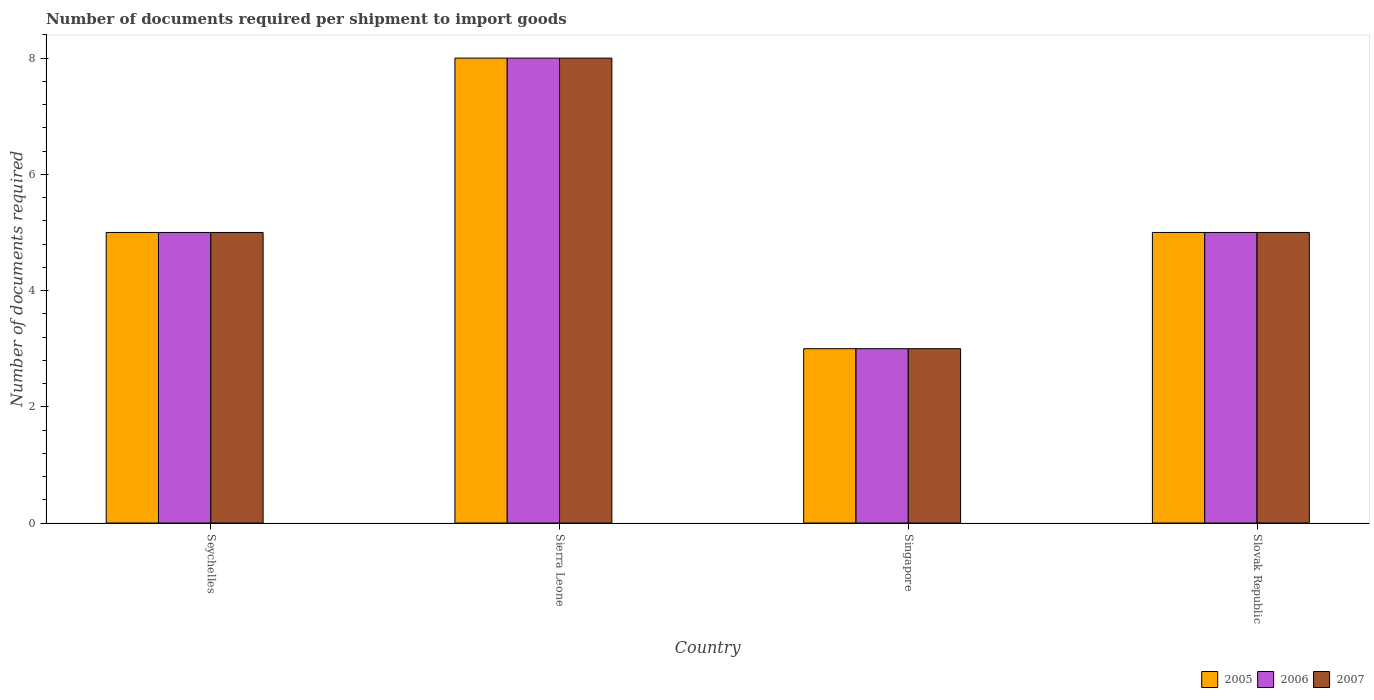How many groups of bars are there?
Offer a very short reply. 4. Are the number of bars per tick equal to the number of legend labels?
Your answer should be compact. Yes. What is the label of the 4th group of bars from the left?
Ensure brevity in your answer.  Slovak Republic. Across all countries, what is the maximum number of documents required per shipment to import goods in 2006?
Ensure brevity in your answer.  8. In which country was the number of documents required per shipment to import goods in 2007 maximum?
Offer a terse response. Sierra Leone. In which country was the number of documents required per shipment to import goods in 2006 minimum?
Your response must be concise. Singapore. What is the difference between the number of documents required per shipment to import goods in 2006 in Seychelles and that in Singapore?
Make the answer very short. 2. What is the average number of documents required per shipment to import goods in 2007 per country?
Give a very brief answer. 5.25. What is the difference between the number of documents required per shipment to import goods of/in 2006 and number of documents required per shipment to import goods of/in 2007 in Seychelles?
Your response must be concise. 0. What is the ratio of the number of documents required per shipment to import goods in 2005 in Seychelles to that in Singapore?
Provide a short and direct response. 1.67. Is the number of documents required per shipment to import goods in 2005 in Seychelles less than that in Sierra Leone?
Ensure brevity in your answer.  Yes. Is the difference between the number of documents required per shipment to import goods in 2006 in Seychelles and Sierra Leone greater than the difference between the number of documents required per shipment to import goods in 2007 in Seychelles and Sierra Leone?
Ensure brevity in your answer.  No. What is the difference between the highest and the second highest number of documents required per shipment to import goods in 2006?
Keep it short and to the point. 3. What is the difference between the highest and the lowest number of documents required per shipment to import goods in 2005?
Make the answer very short. 5. What does the 3rd bar from the left in Sierra Leone represents?
Offer a terse response. 2007. What does the 2nd bar from the right in Sierra Leone represents?
Keep it short and to the point. 2006. How many countries are there in the graph?
Your answer should be very brief. 4. Does the graph contain any zero values?
Keep it short and to the point. No. Where does the legend appear in the graph?
Offer a terse response. Bottom right. What is the title of the graph?
Provide a succinct answer. Number of documents required per shipment to import goods. Does "2005" appear as one of the legend labels in the graph?
Provide a succinct answer. Yes. What is the label or title of the Y-axis?
Offer a terse response. Number of documents required. What is the Number of documents required in 2007 in Seychelles?
Ensure brevity in your answer.  5. What is the Number of documents required of 2006 in Sierra Leone?
Your answer should be compact. 8. What is the Number of documents required in 2007 in Sierra Leone?
Provide a succinct answer. 8. What is the Number of documents required in 2005 in Singapore?
Keep it short and to the point. 3. What is the Number of documents required in 2007 in Singapore?
Offer a very short reply. 3. Across all countries, what is the maximum Number of documents required in 2005?
Your response must be concise. 8. Across all countries, what is the maximum Number of documents required of 2007?
Offer a terse response. 8. Across all countries, what is the minimum Number of documents required of 2006?
Ensure brevity in your answer.  3. Across all countries, what is the minimum Number of documents required in 2007?
Make the answer very short. 3. What is the total Number of documents required of 2005 in the graph?
Keep it short and to the point. 21. What is the total Number of documents required of 2007 in the graph?
Make the answer very short. 21. What is the difference between the Number of documents required in 2005 in Seychelles and that in Sierra Leone?
Ensure brevity in your answer.  -3. What is the difference between the Number of documents required in 2006 in Seychelles and that in Sierra Leone?
Provide a short and direct response. -3. What is the difference between the Number of documents required in 2007 in Seychelles and that in Sierra Leone?
Your response must be concise. -3. What is the difference between the Number of documents required of 2007 in Seychelles and that in Singapore?
Your answer should be compact. 2. What is the difference between the Number of documents required of 2005 in Seychelles and that in Slovak Republic?
Your answer should be compact. 0. What is the difference between the Number of documents required in 2006 in Seychelles and that in Slovak Republic?
Your answer should be compact. 0. What is the difference between the Number of documents required of 2005 in Sierra Leone and that in Singapore?
Ensure brevity in your answer.  5. What is the difference between the Number of documents required of 2006 in Sierra Leone and that in Slovak Republic?
Provide a succinct answer. 3. What is the difference between the Number of documents required in 2007 in Sierra Leone and that in Slovak Republic?
Offer a terse response. 3. What is the difference between the Number of documents required in 2005 in Seychelles and the Number of documents required in 2007 in Sierra Leone?
Provide a succinct answer. -3. What is the difference between the Number of documents required in 2005 in Seychelles and the Number of documents required in 2007 in Singapore?
Ensure brevity in your answer.  2. What is the difference between the Number of documents required in 2005 in Sierra Leone and the Number of documents required in 2006 in Singapore?
Offer a very short reply. 5. What is the difference between the Number of documents required in 2005 in Sierra Leone and the Number of documents required in 2007 in Singapore?
Ensure brevity in your answer.  5. What is the difference between the Number of documents required of 2006 in Sierra Leone and the Number of documents required of 2007 in Singapore?
Offer a very short reply. 5. What is the difference between the Number of documents required in 2005 in Sierra Leone and the Number of documents required in 2006 in Slovak Republic?
Make the answer very short. 3. What is the difference between the Number of documents required of 2005 in Sierra Leone and the Number of documents required of 2007 in Slovak Republic?
Ensure brevity in your answer.  3. What is the difference between the Number of documents required in 2006 in Sierra Leone and the Number of documents required in 2007 in Slovak Republic?
Provide a succinct answer. 3. What is the difference between the Number of documents required of 2005 in Singapore and the Number of documents required of 2006 in Slovak Republic?
Your answer should be very brief. -2. What is the difference between the Number of documents required of 2005 in Singapore and the Number of documents required of 2007 in Slovak Republic?
Your answer should be compact. -2. What is the average Number of documents required in 2005 per country?
Offer a terse response. 5.25. What is the average Number of documents required of 2006 per country?
Ensure brevity in your answer.  5.25. What is the average Number of documents required of 2007 per country?
Provide a succinct answer. 5.25. What is the difference between the Number of documents required of 2005 and Number of documents required of 2007 in Seychelles?
Offer a very short reply. 0. What is the difference between the Number of documents required of 2005 and Number of documents required of 2006 in Sierra Leone?
Make the answer very short. 0. What is the difference between the Number of documents required in 2006 and Number of documents required in 2007 in Sierra Leone?
Your answer should be very brief. 0. What is the difference between the Number of documents required of 2005 and Number of documents required of 2007 in Slovak Republic?
Your response must be concise. 0. What is the difference between the Number of documents required of 2006 and Number of documents required of 2007 in Slovak Republic?
Your answer should be very brief. 0. What is the ratio of the Number of documents required of 2005 in Seychelles to that in Sierra Leone?
Ensure brevity in your answer.  0.62. What is the ratio of the Number of documents required of 2006 in Seychelles to that in Sierra Leone?
Ensure brevity in your answer.  0.62. What is the ratio of the Number of documents required in 2006 in Seychelles to that in Singapore?
Give a very brief answer. 1.67. What is the ratio of the Number of documents required in 2007 in Seychelles to that in Slovak Republic?
Your answer should be very brief. 1. What is the ratio of the Number of documents required in 2005 in Sierra Leone to that in Singapore?
Offer a very short reply. 2.67. What is the ratio of the Number of documents required in 2006 in Sierra Leone to that in Singapore?
Provide a succinct answer. 2.67. What is the ratio of the Number of documents required of 2007 in Sierra Leone to that in Singapore?
Your answer should be very brief. 2.67. What is the ratio of the Number of documents required of 2005 in Sierra Leone to that in Slovak Republic?
Your response must be concise. 1.6. What is the ratio of the Number of documents required of 2007 in Sierra Leone to that in Slovak Republic?
Your response must be concise. 1.6. What is the ratio of the Number of documents required in 2006 in Singapore to that in Slovak Republic?
Offer a terse response. 0.6. What is the ratio of the Number of documents required of 2007 in Singapore to that in Slovak Republic?
Your response must be concise. 0.6. What is the difference between the highest and the second highest Number of documents required in 2006?
Provide a short and direct response. 3. What is the difference between the highest and the lowest Number of documents required of 2005?
Offer a very short reply. 5. 